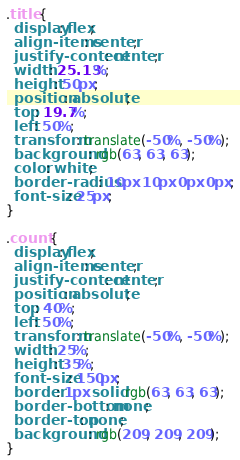Convert code to text. <code><loc_0><loc_0><loc_500><loc_500><_CSS_>.title {
  display: flex;
  align-items: center;
  justify-content: center;
  width: 25.13%;
  height: 50px;
  position: absolute;
  top: 19.7%;
  left: 50%;
  transform: translate(-50%, -50%);
  background: rgb(63, 63, 63);
  color: white;
  border-radius: 10px 10px 0px 0px;
  font-size: 25px;
}

.count {
  display: flex;
  align-items: center;
  justify-content: center;
  position: absolute;
  top: 40%;
  left: 50%;
  transform: translate(-50%, -50%);
  width: 25%;
  height: 35%;
  font-size: 150px;
  border: 1px solid rgb(63, 63, 63);
  border-bottom: none;
  border-top: none;
  background: rgb(209, 209, 209);
}</code> 